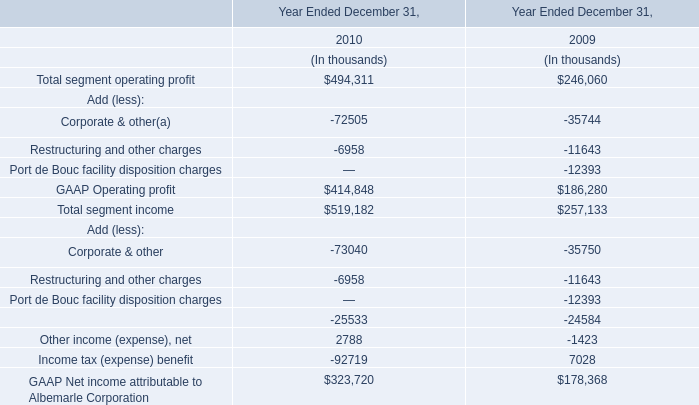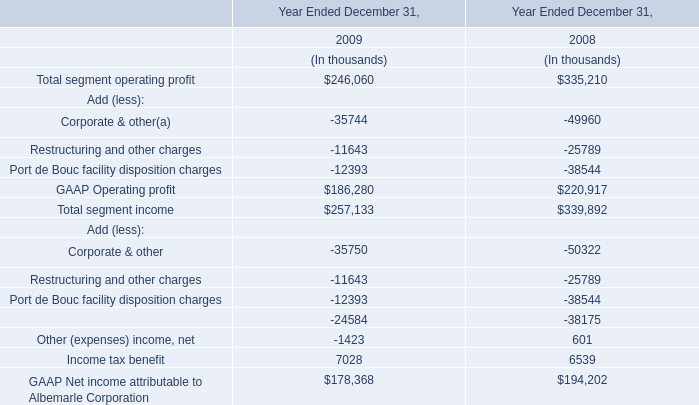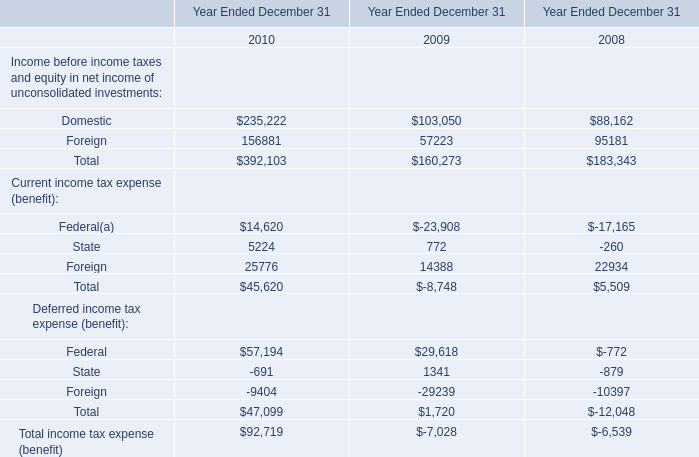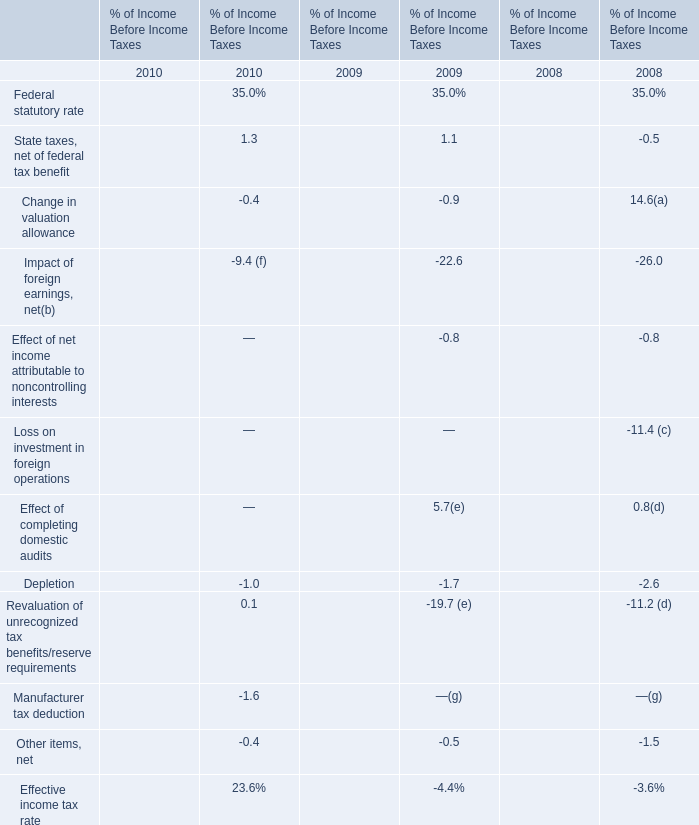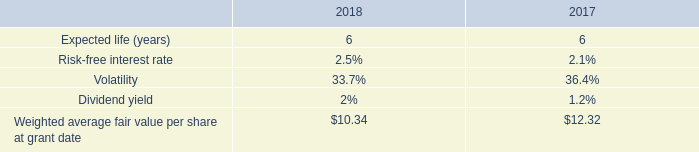Which year is Income before income taxes and equity in net income of unconsolidated investments the highest 
Answer: 392103. 